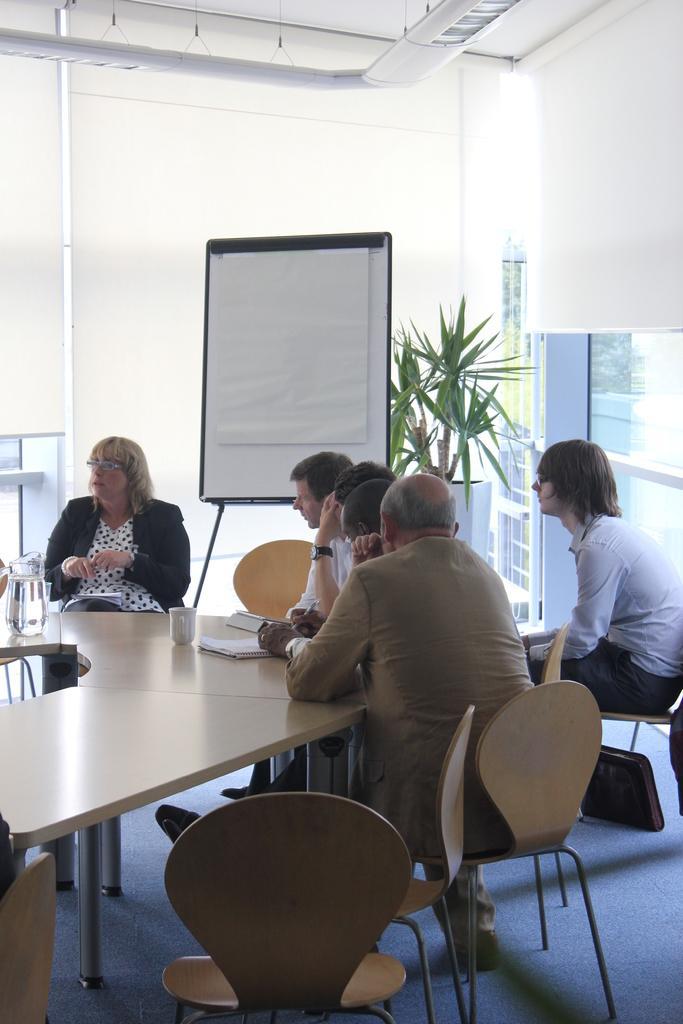Please provide a concise description of this image. These persons are sitting on a chair. On this table there is a jar, cup and book. Backside of this person there is a whiteboard. Backside of this whiteboard there is a plant. 